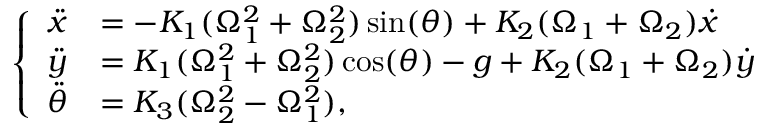<formula> <loc_0><loc_0><loc_500><loc_500>\left \{ \begin{array} { l l } { \ddot { x } } & { = - K _ { 1 } ( \Omega _ { 1 } ^ { 2 } + \Omega _ { 2 } ^ { 2 } ) \sin ( \theta ) + K _ { 2 } ( \Omega _ { 1 } + \Omega _ { 2 } ) \dot { x } } \\ { \ddot { y } } & { = K _ { 1 } ( \Omega _ { 1 } ^ { 2 } + \Omega _ { 2 } ^ { 2 } ) \cos ( \theta ) - g + K _ { 2 } ( \Omega _ { 1 } + \Omega _ { 2 } ) \dot { y } } \\ { \ddot { \theta } } & { = K _ { 3 } ( \Omega _ { 2 } ^ { 2 } - \Omega _ { 1 } ^ { 2 } ) , } \end{array}</formula> 